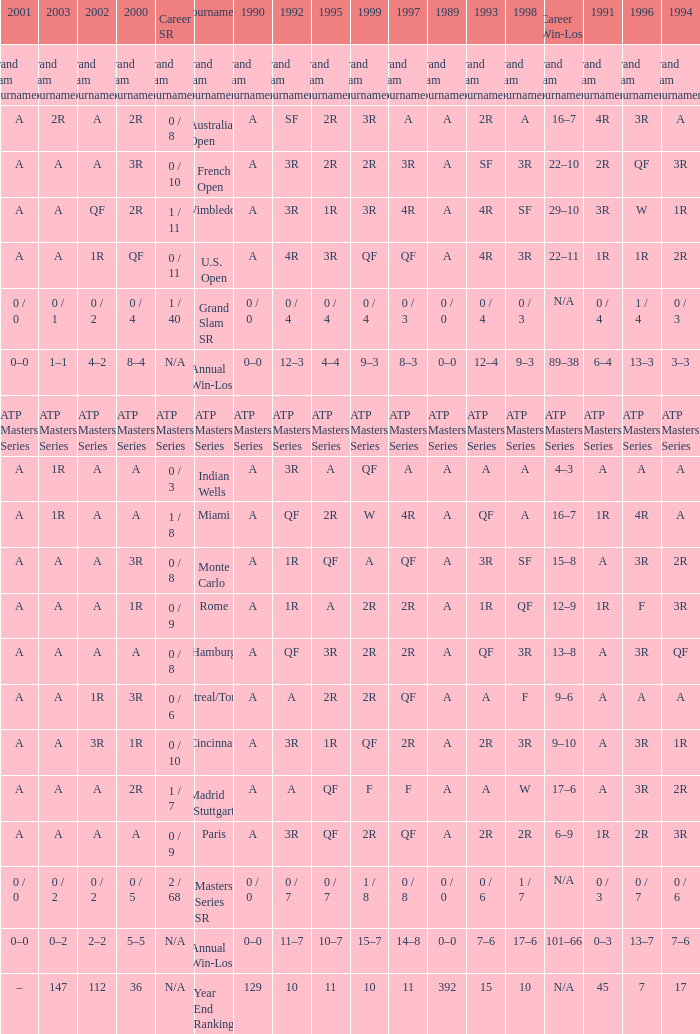For the 2000 indian wells tournament, what was the 1995 value of a? A. 